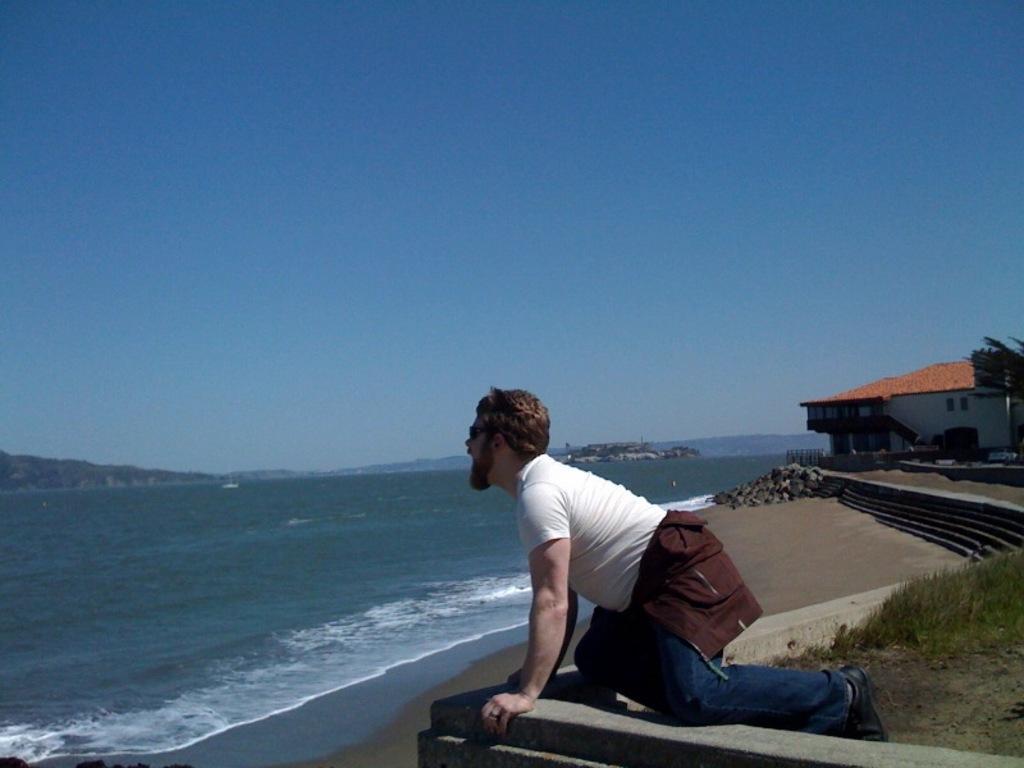Can you describe this image briefly? In this image we can see a person, wall and other objects. In the background of the image there are water, house, steps, tree and other objects. At the top of the image there is the sky. 